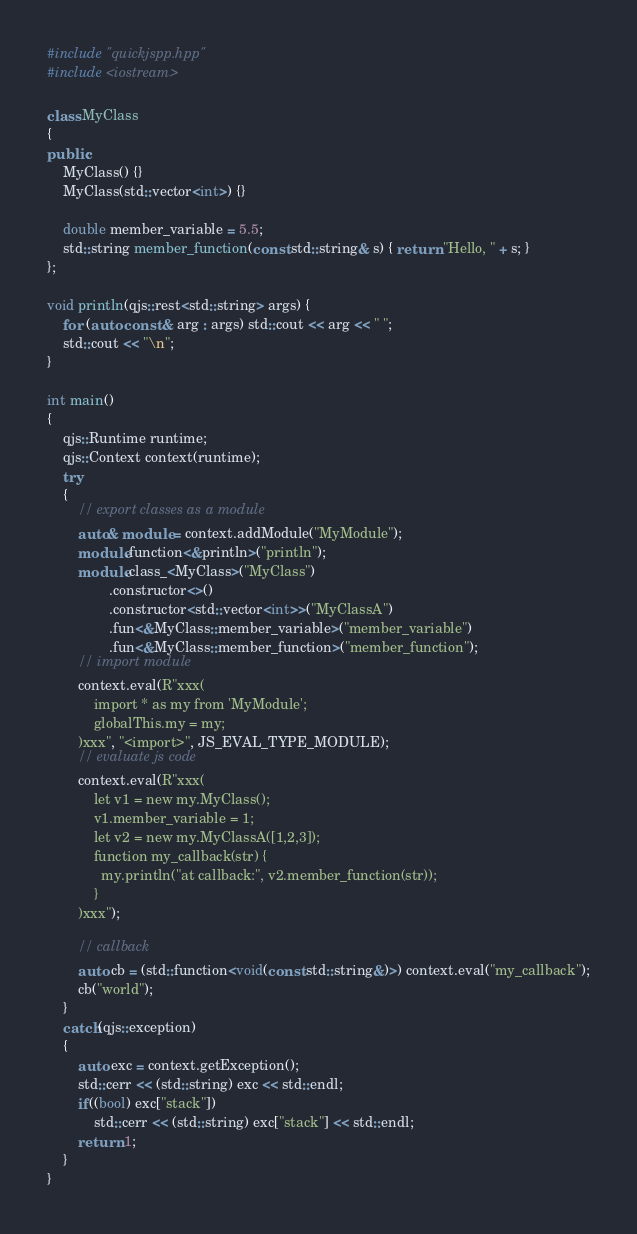Convert code to text. <code><loc_0><loc_0><loc_500><loc_500><_C++_>#include "quickjspp.hpp"
#include <iostream>

class MyClass
{
public:
    MyClass() {}
    MyClass(std::vector<int>) {}

    double member_variable = 5.5;
    std::string member_function(const std::string& s) { return "Hello, " + s; }
};

void println(qjs::rest<std::string> args) {
    for (auto const & arg : args) std::cout << arg << " ";
    std::cout << "\n";
}

int main()
{
    qjs::Runtime runtime;
    qjs::Context context(runtime);
    try
    {
        // export classes as a module
        auto& module = context.addModule("MyModule");
        module.function<&println>("println");
        module.class_<MyClass>("MyClass")
                .constructor<>()
                .constructor<std::vector<int>>("MyClassA")
                .fun<&MyClass::member_variable>("member_variable")
                .fun<&MyClass::member_function>("member_function");
        // import module
        context.eval(R"xxx(
            import * as my from 'MyModule';
            globalThis.my = my;
        )xxx", "<import>", JS_EVAL_TYPE_MODULE);
        // evaluate js code
        context.eval(R"xxx(
            let v1 = new my.MyClass();
            v1.member_variable = 1;
            let v2 = new my.MyClassA([1,2,3]);
            function my_callback(str) {
              my.println("at callback:", v2.member_function(str));
            }
        )xxx");

        // callback
        auto cb = (std::function<void(const std::string&)>) context.eval("my_callback");
        cb("world");
    }
    catch(qjs::exception)
    {
        auto exc = context.getException();
        std::cerr << (std::string) exc << std::endl;
        if((bool) exc["stack"])
            std::cerr << (std::string) exc["stack"] << std::endl;
        return 1;
    }
}
</code> 